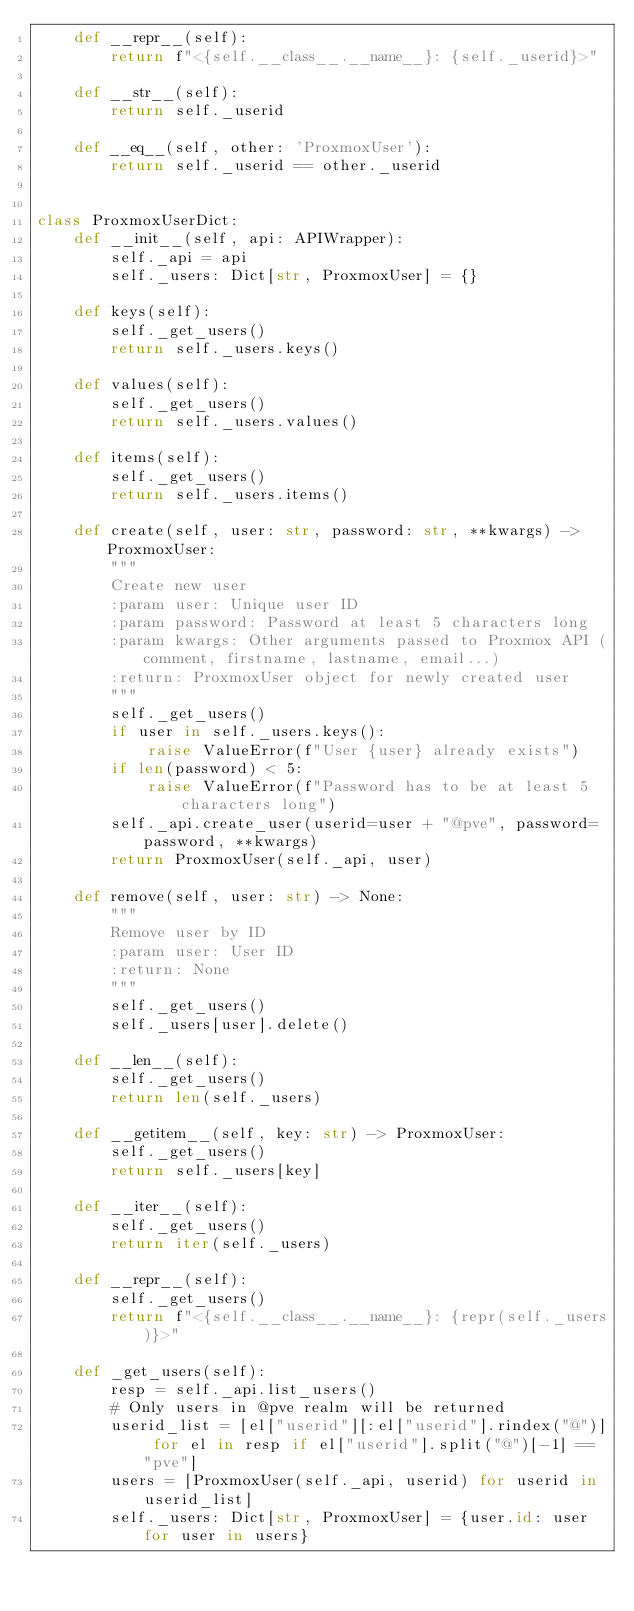<code> <loc_0><loc_0><loc_500><loc_500><_Python_>    def __repr__(self):
        return f"<{self.__class__.__name__}: {self._userid}>"

    def __str__(self):
        return self._userid

    def __eq__(self, other: 'ProxmoxUser'):
        return self._userid == other._userid


class ProxmoxUserDict:
    def __init__(self, api: APIWrapper):
        self._api = api
        self._users: Dict[str, ProxmoxUser] = {}

    def keys(self):
        self._get_users()
        return self._users.keys()

    def values(self):
        self._get_users()
        return self._users.values()

    def items(self):
        self._get_users()
        return self._users.items()

    def create(self, user: str, password: str, **kwargs) -> ProxmoxUser:
        """
        Create new user
        :param user: Unique user ID
        :param password: Password at least 5 characters long
        :param kwargs: Other arguments passed to Proxmox API (comment, firstname, lastname, email...)
        :return: ProxmoxUser object for newly created user
        """
        self._get_users()
        if user in self._users.keys():
            raise ValueError(f"User {user} already exists")
        if len(password) < 5:
            raise ValueError(f"Password has to be at least 5 characters long")
        self._api.create_user(userid=user + "@pve", password=password, **kwargs)
        return ProxmoxUser(self._api, user)

    def remove(self, user: str) -> None:
        """
        Remove user by ID
        :param user: User ID
        :return: None
        """
        self._get_users()
        self._users[user].delete()

    def __len__(self):
        self._get_users()
        return len(self._users)

    def __getitem__(self, key: str) -> ProxmoxUser:
        self._get_users()
        return self._users[key]

    def __iter__(self):
        self._get_users()
        return iter(self._users)

    def __repr__(self):
        self._get_users()
        return f"<{self.__class__.__name__}: {repr(self._users)}>"

    def _get_users(self):
        resp = self._api.list_users()
        # Only users in @pve realm will be returned
        userid_list = [el["userid"][:el["userid"].rindex("@")] for el in resp if el["userid"].split("@")[-1] == "pve"]
        users = [ProxmoxUser(self._api, userid) for userid in userid_list]
        self._users: Dict[str, ProxmoxUser] = {user.id: user for user in users}
</code> 